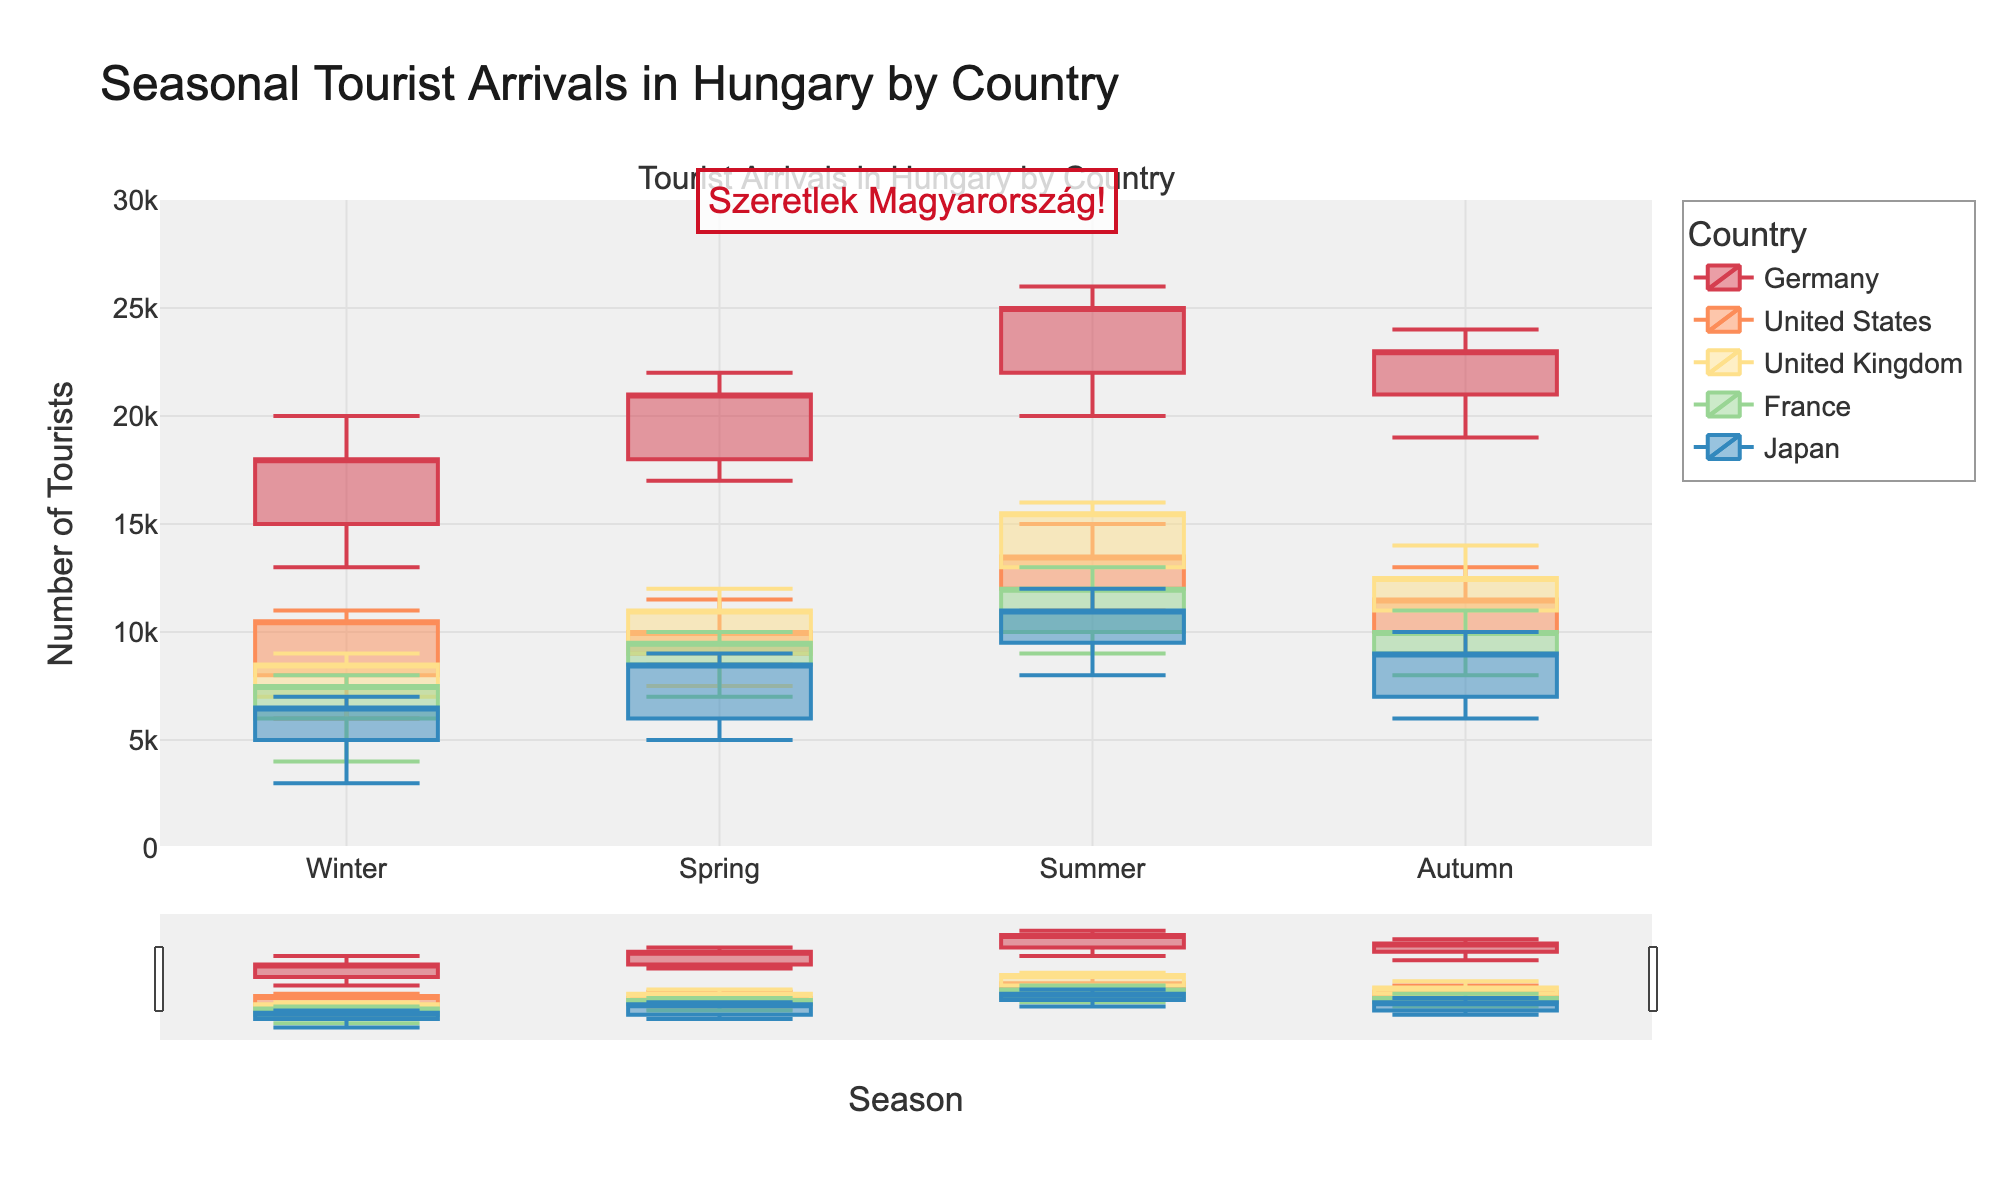what is the title of the figure? The title is located at the top of the figure and serves as a summary of what the figure represents. In this figure, the title reads "Seasonal Tourist Arrivals in Hungary by Country".
Answer: Seasonal Tourist Arrivals in Hungary by Country Which season sees the highest number of tourists from Germany? To determine this, we note the highest *High* value for Germany, which is 26000. Review the season labels to identify that this peak is in Summer.
Answer: Summer How many tourists came from the United States during Winter? This is indicated by the *Close* value for Winter under the United States section. The *Close* value for tourists from the United States in Winter is 10500.
Answer: 10500 Comparing Summer arrivals, which country has the lowest number of tourists and what is that number? To find the country with the lowest arrival in Summer, look at all countries' *Low* values for Summer. Japan has the lowest number, which is 8000.
Answer: Japan, 8000 What is the range of tourist arrivals from France in Autumn? The range is derived by subtracting the *Low* value from the *High* value of France in Autumn: 11000 - 8000 = 3000.
Answer: 3000 In which season does Japan have the highest number of tourists? Identify the highest *High* value for Japan across all seasons to determine the season with the highest number. The peak of 12000 occurs in Summer.
Answer: Summer What's the average number of tourists from the United Kingdom in Spring and Autumn combined? Add the *Close* values for Spring and Autumn for the United Kingdom: 11000 + 12500 = 23500. Then divide by 2 to get the average: 23500 / 2 = 11750.
Answer: 11750 How does the number of tourists from Germany in Winter compare to those from France in the same season? Compare the *Close* values for Winter: Germany = 18000, France = 7500. 18000 is more than 7500.
Answer: Germany has more tourists than France What is the total number of tourists from the United Kingdom across all seasons? Sum the *Close* values for all seasons from the United Kingdom: 8500 (Winter) + 11000 (Spring) + 15500 (Summer) + 12500 (Autumn) = 47500.
Answer: 47500 Which country shows the largest drop in the number of tourists from Summer to Autumn? By comparing the *Close* values between Summer and Autumn for each country, determine the differences and find the largest. Germany drops from 25000 (Summer) to 23000 (Autumn), a drop of 2000, which is the highest drop.
Answer: Germany 